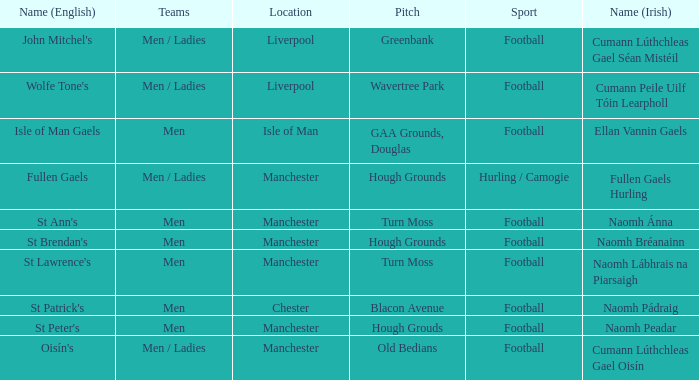What is the English Name of the Location in Chester? St Patrick's. 